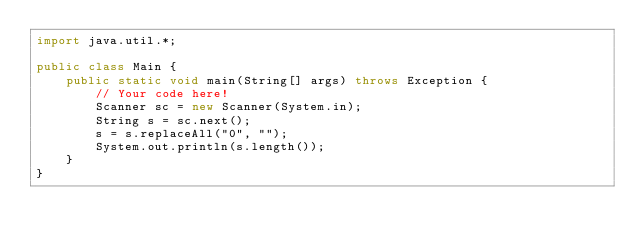Convert code to text. <code><loc_0><loc_0><loc_500><loc_500><_Java_>import java.util.*;

public class Main {
    public static void main(String[] args) throws Exception {
        // Your code here!
        Scanner sc = new Scanner(System.in);
        String s = sc.next();
        s = s.replaceAll("0", "");
        System.out.println(s.length());
    }
}
</code> 